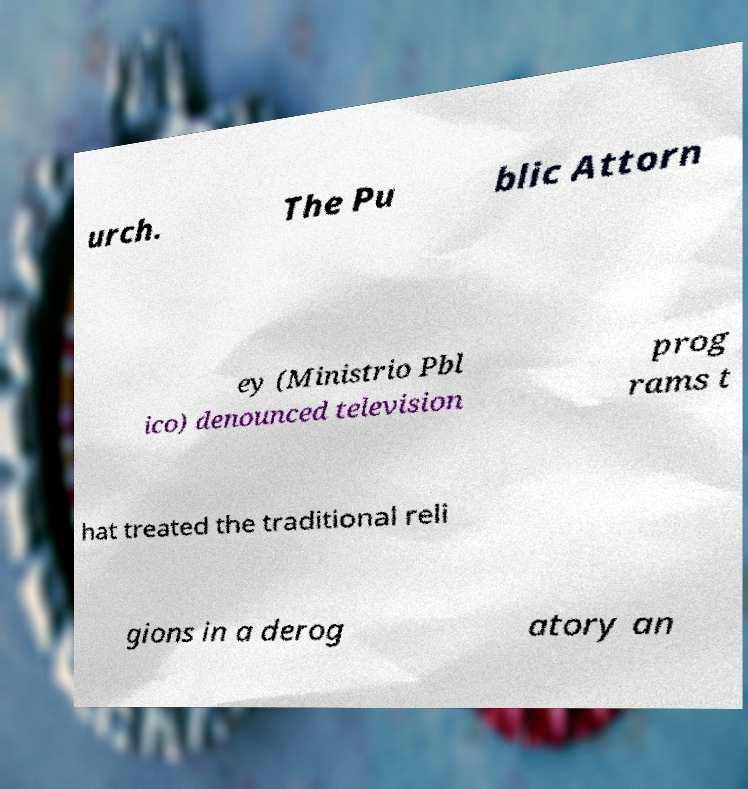Please read and relay the text visible in this image. What does it say? urch. The Pu blic Attorn ey (Ministrio Pbl ico) denounced television prog rams t hat treated the traditional reli gions in a derog atory an 